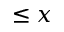Convert formula to latex. <formula><loc_0><loc_0><loc_500><loc_500>\leq x</formula> 